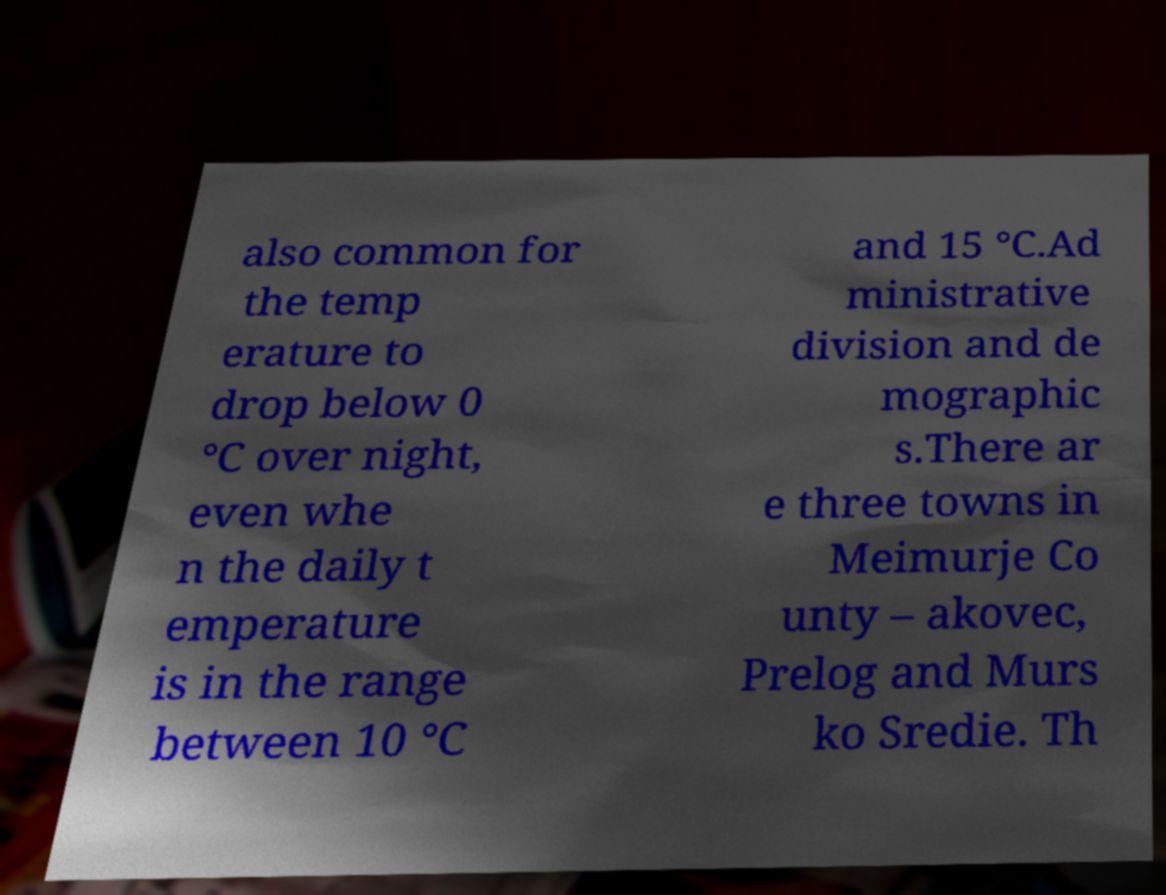Could you extract and type out the text from this image? also common for the temp erature to drop below 0 °C over night, even whe n the daily t emperature is in the range between 10 °C and 15 °C.Ad ministrative division and de mographic s.There ar e three towns in Meimurje Co unty – akovec, Prelog and Murs ko Sredie. Th 